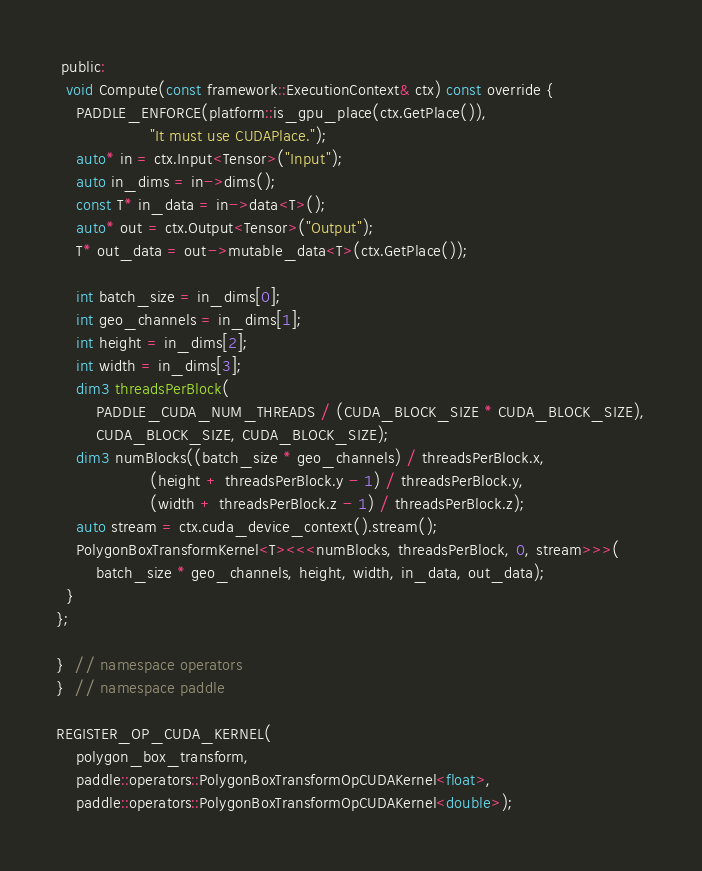Convert code to text. <code><loc_0><loc_0><loc_500><loc_500><_Cuda_> public:
  void Compute(const framework::ExecutionContext& ctx) const override {
    PADDLE_ENFORCE(platform::is_gpu_place(ctx.GetPlace()),
                   "It must use CUDAPlace.");
    auto* in = ctx.Input<Tensor>("Input");
    auto in_dims = in->dims();
    const T* in_data = in->data<T>();
    auto* out = ctx.Output<Tensor>("Output");
    T* out_data = out->mutable_data<T>(ctx.GetPlace());

    int batch_size = in_dims[0];
    int geo_channels = in_dims[1];
    int height = in_dims[2];
    int width = in_dims[3];
    dim3 threadsPerBlock(
        PADDLE_CUDA_NUM_THREADS / (CUDA_BLOCK_SIZE * CUDA_BLOCK_SIZE),
        CUDA_BLOCK_SIZE, CUDA_BLOCK_SIZE);
    dim3 numBlocks((batch_size * geo_channels) / threadsPerBlock.x,
                   (height + threadsPerBlock.y - 1) / threadsPerBlock.y,
                   (width + threadsPerBlock.z - 1) / threadsPerBlock.z);
    auto stream = ctx.cuda_device_context().stream();
    PolygonBoxTransformKernel<T><<<numBlocks, threadsPerBlock, 0, stream>>>(
        batch_size * geo_channels, height, width, in_data, out_data);
  }
};

}  // namespace operators
}  // namespace paddle

REGISTER_OP_CUDA_KERNEL(
    polygon_box_transform,
    paddle::operators::PolygonBoxTransformOpCUDAKernel<float>,
    paddle::operators::PolygonBoxTransformOpCUDAKernel<double>);
</code> 